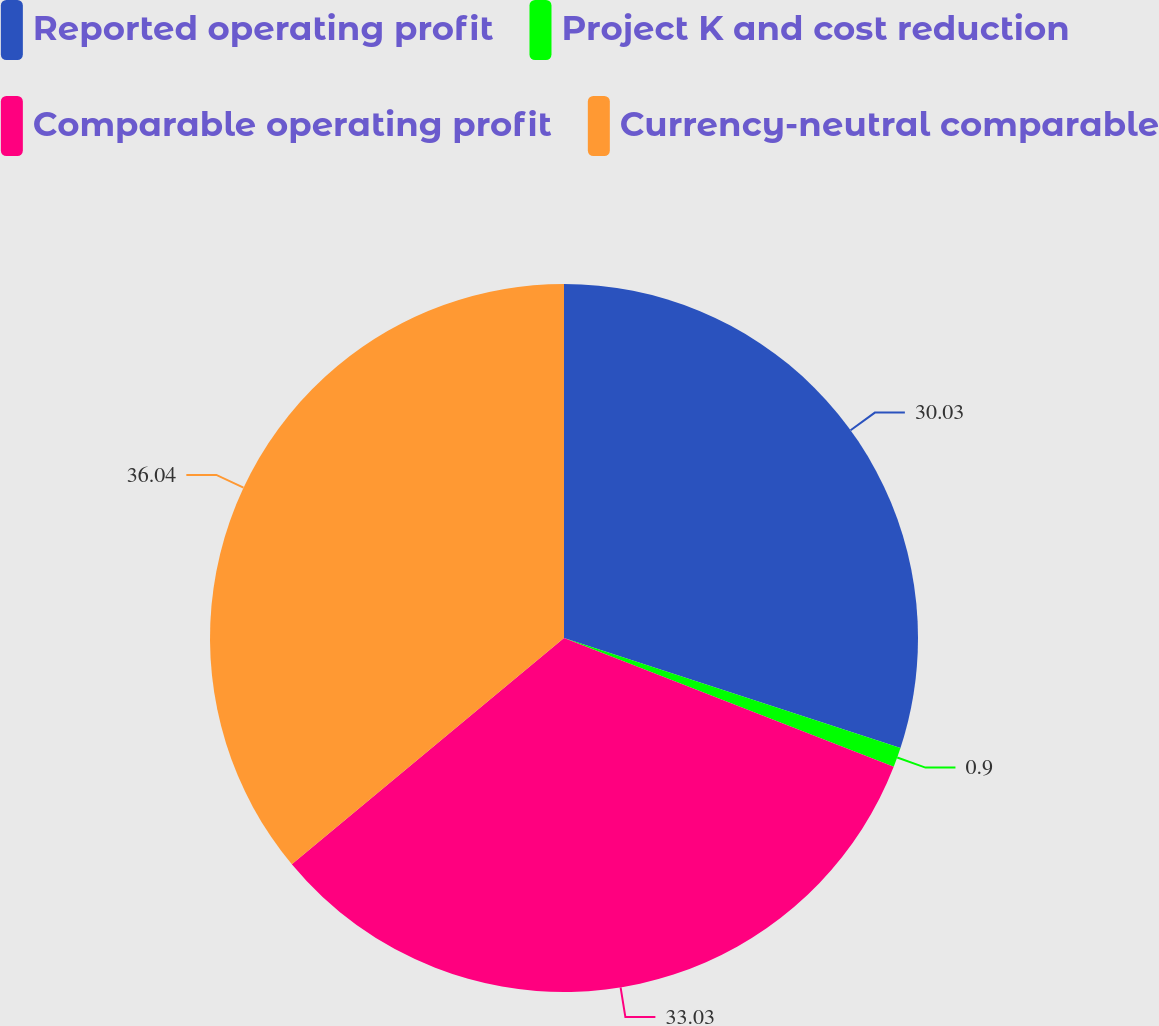Convert chart. <chart><loc_0><loc_0><loc_500><loc_500><pie_chart><fcel>Reported operating profit<fcel>Project K and cost reduction<fcel>Comparable operating profit<fcel>Currency-neutral comparable<nl><fcel>30.03%<fcel>0.9%<fcel>33.03%<fcel>36.04%<nl></chart> 